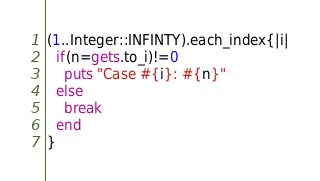<code> <loc_0><loc_0><loc_500><loc_500><_Ruby_>(1..Integer::INFINTY).each_index{|i|
  if(n=gets.to_i)!=0
    puts "Case #{i}: #{n}"
  else
    break
  end
}</code> 